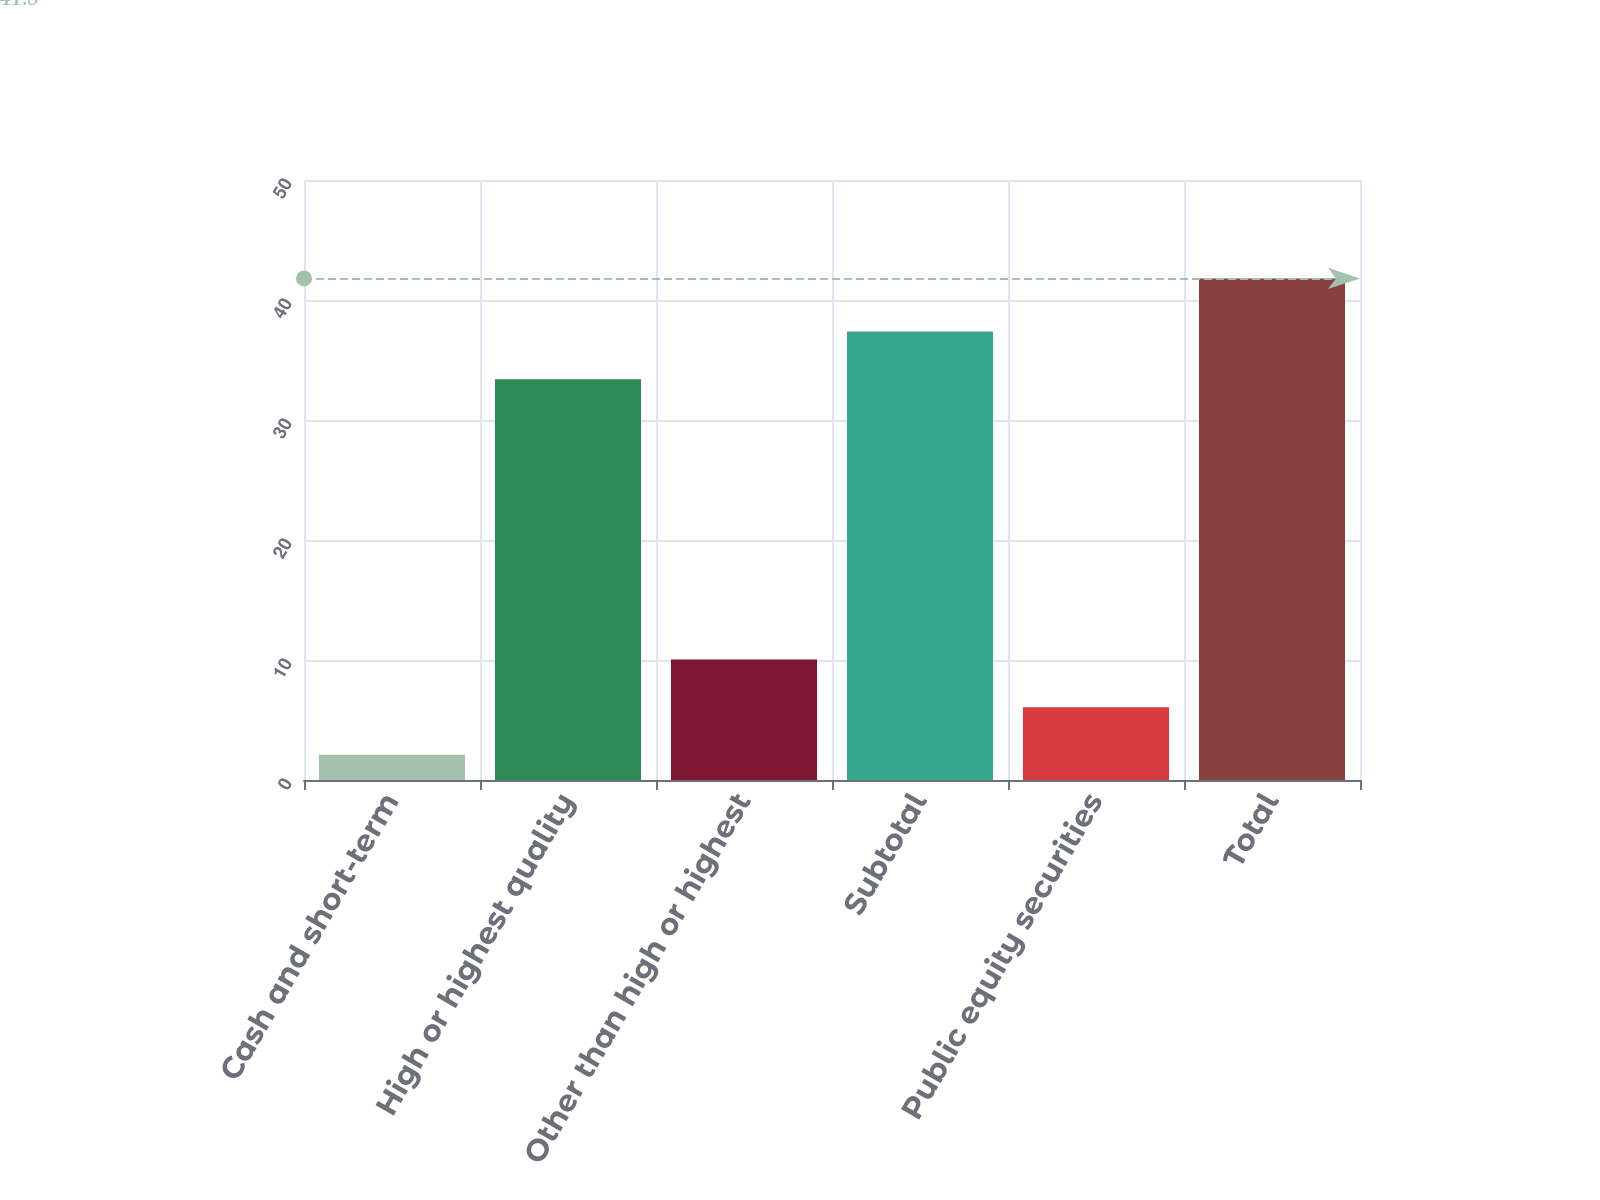<chart> <loc_0><loc_0><loc_500><loc_500><bar_chart><fcel>Cash and short-term<fcel>High or highest quality<fcel>Other than high or highest<fcel>Subtotal<fcel>Public equity securities<fcel>Total<nl><fcel>2.1<fcel>33.4<fcel>10.04<fcel>37.37<fcel>6.07<fcel>41.8<nl></chart> 